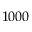<formula> <loc_0><loc_0><loc_500><loc_500>1 0 0 0</formula> 